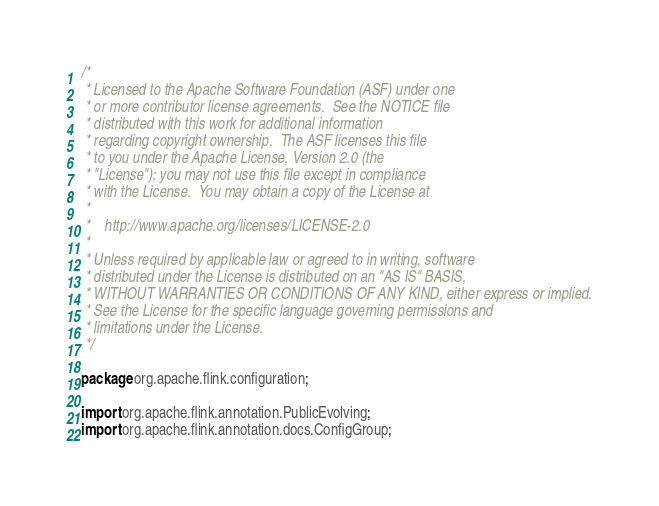Convert code to text. <code><loc_0><loc_0><loc_500><loc_500><_Java_>/*
 * Licensed to the Apache Software Foundation (ASF) under one
 * or more contributor license agreements.  See the NOTICE file
 * distributed with this work for additional information
 * regarding copyright ownership.  The ASF licenses this file
 * to you under the Apache License, Version 2.0 (the
 * "License"); you may not use this file except in compliance
 * with the License.  You may obtain a copy of the License at
 *
 *    http://www.apache.org/licenses/LICENSE-2.0
 *
 * Unless required by applicable law or agreed to in writing, software
 * distributed under the License is distributed on an "AS IS" BASIS,
 * WITHOUT WARRANTIES OR CONDITIONS OF ANY KIND, either express or implied.
 * See the License for the specific language governing permissions and
 * limitations under the License.
 */

package org.apache.flink.configuration;

import org.apache.flink.annotation.PublicEvolving;
import org.apache.flink.annotation.docs.ConfigGroup;</code> 